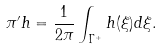Convert formula to latex. <formula><loc_0><loc_0><loc_500><loc_500>\pi ^ { \prime } h = \frac { 1 } { 2 \pi } \int _ { \Gamma ^ { + } } h ( \xi ) d \xi .</formula> 